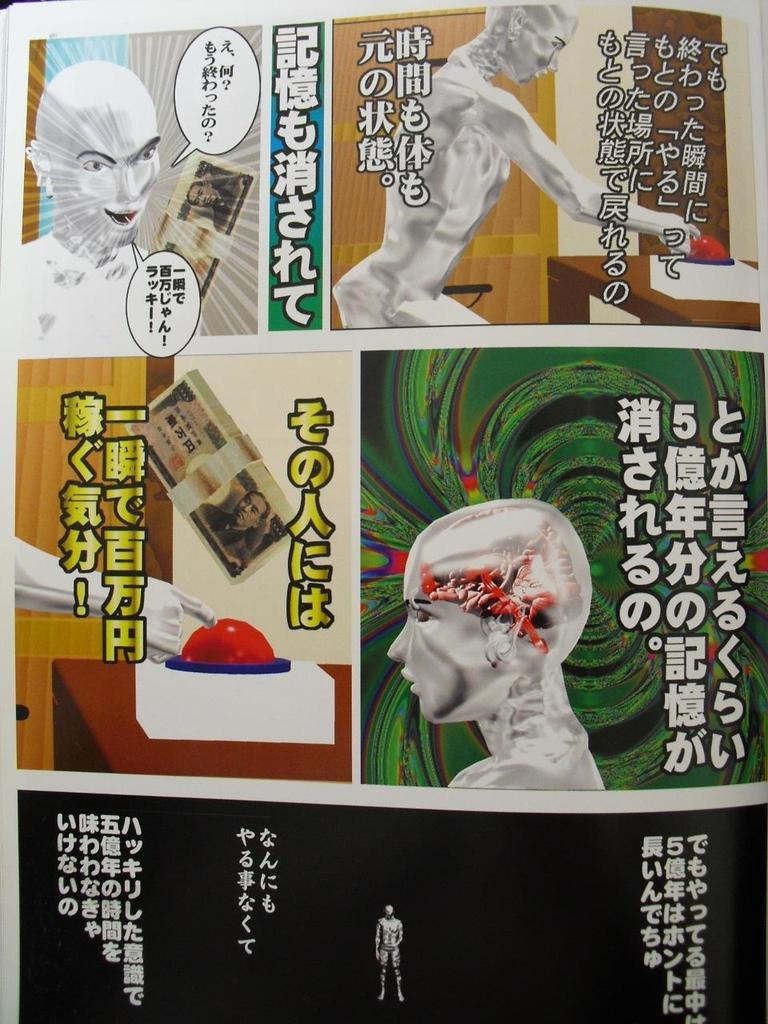What type of artwork is depicted in the image? The image is a collage. What elements are included in the collage? The collage contains text and images. What type of beam can be seen supporting the pig in the cemetery in the image? There is no beam, pig, or cemetery present in the image; it is a collage containing text and images. 